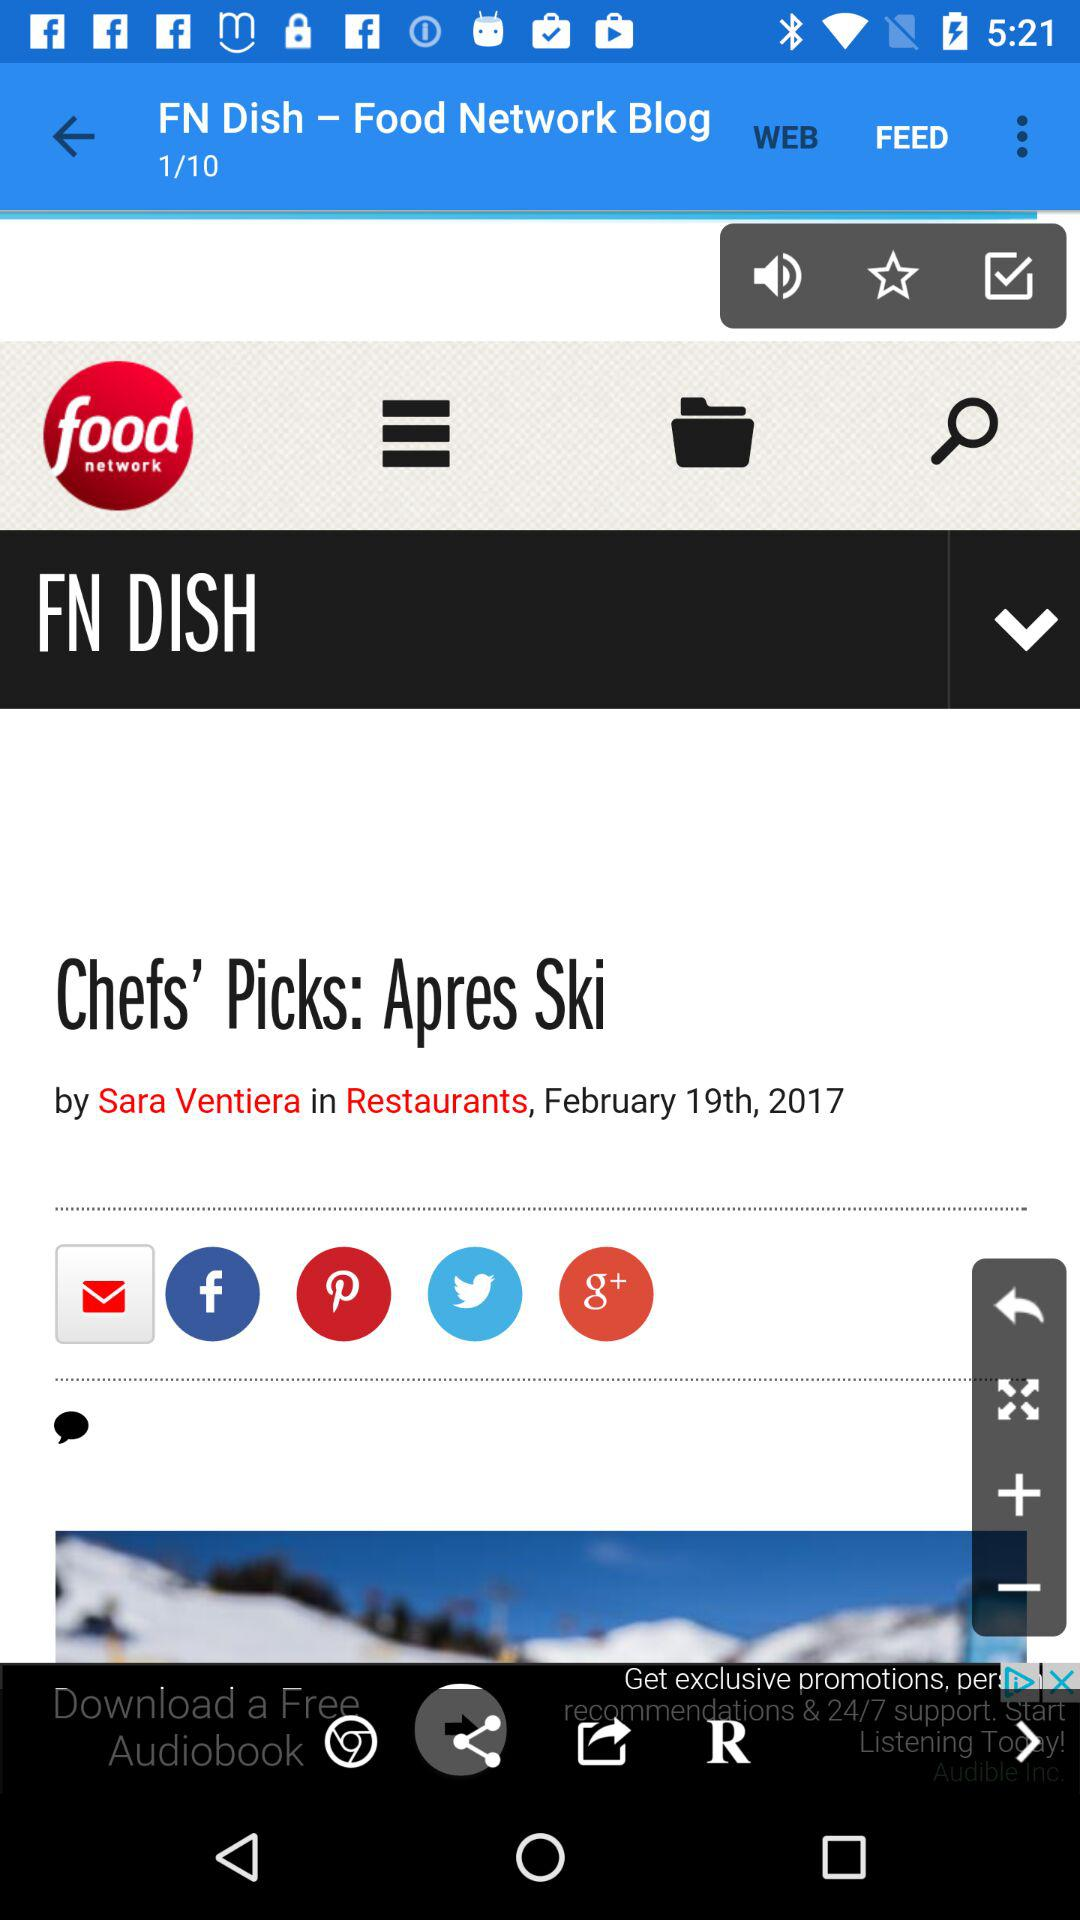How many pages in total for "Food Networking Blog"? There are a total of 10 pages. 